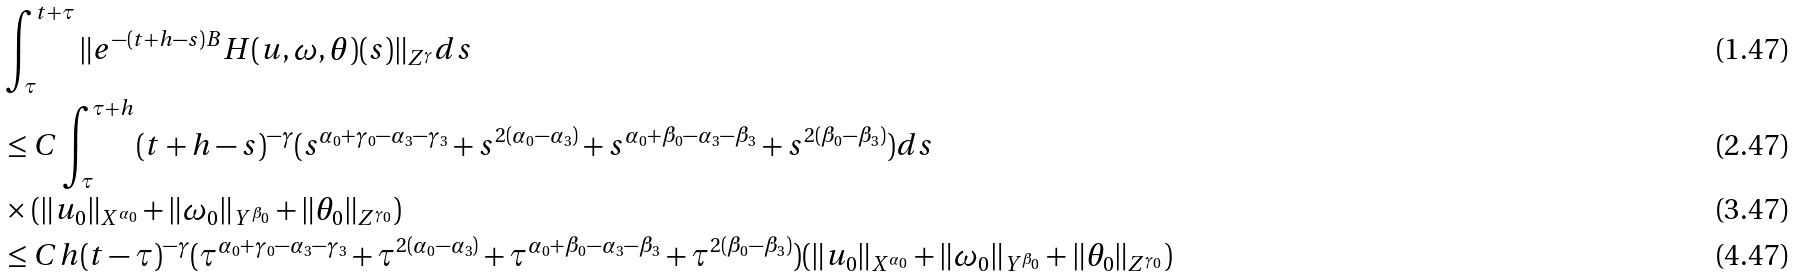Convert formula to latex. <formula><loc_0><loc_0><loc_500><loc_500>& \int ^ { t + \tau } _ { \tau } \| e ^ { - ( t + h - s ) B } H ( u , \omega , \theta ) ( s ) \| _ { Z ^ { \gamma } } d s \\ & \leq C \int ^ { \tau + h } _ { \tau } ( t + h - s ) ^ { - \gamma } ( s ^ { \alpha _ { 0 } + \gamma _ { 0 } - \alpha _ { 3 } - \gamma _ { 3 } } + s ^ { 2 ( \alpha _ { 0 } - \alpha _ { 3 } ) } + s ^ { \alpha _ { 0 } + \beta _ { 0 } - \alpha _ { 3 } - \beta _ { 3 } } + s ^ { 2 ( \beta _ { 0 } - \beta _ { 3 } ) } ) d s \\ & \times ( \| u _ { 0 } \| _ { X ^ { \alpha _ { 0 } } } + \| \omega _ { 0 } \| _ { Y ^ { \beta _ { 0 } } } + \| \theta _ { 0 } \| _ { Z ^ { \gamma _ { 0 } } } ) \\ & \leq C h ( t - \tau ) ^ { - \gamma } ( \tau ^ { \alpha _ { 0 } + \gamma _ { 0 } - \alpha _ { 3 } - \gamma _ { 3 } } + \tau ^ { 2 ( \alpha _ { 0 } - \alpha _ { 3 } ) } + \tau ^ { \alpha _ { 0 } + \beta _ { 0 } - \alpha _ { 3 } - \beta _ { 3 } } + \tau ^ { 2 ( \beta _ { 0 } - \beta _ { 3 } ) } ) ( \| u _ { 0 } \| _ { X ^ { \alpha _ { 0 } } } + \| \omega _ { 0 } \| _ { Y ^ { \beta _ { 0 } } } + \| \theta _ { 0 } \| _ { Z ^ { \gamma _ { 0 } } } )</formula> 